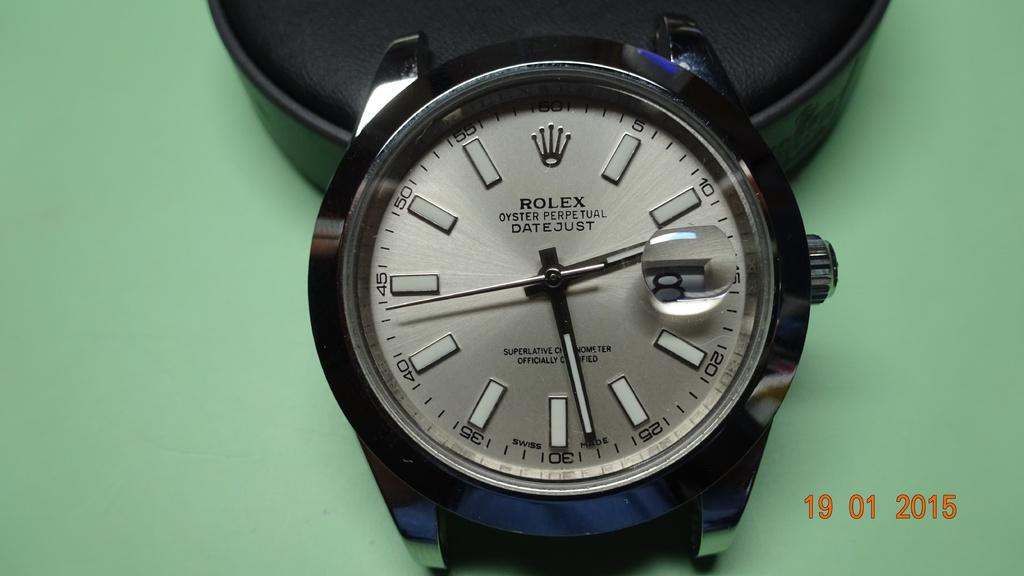<image>
Summarize the visual content of the image. A  fancy rolex watch sitting on a table 